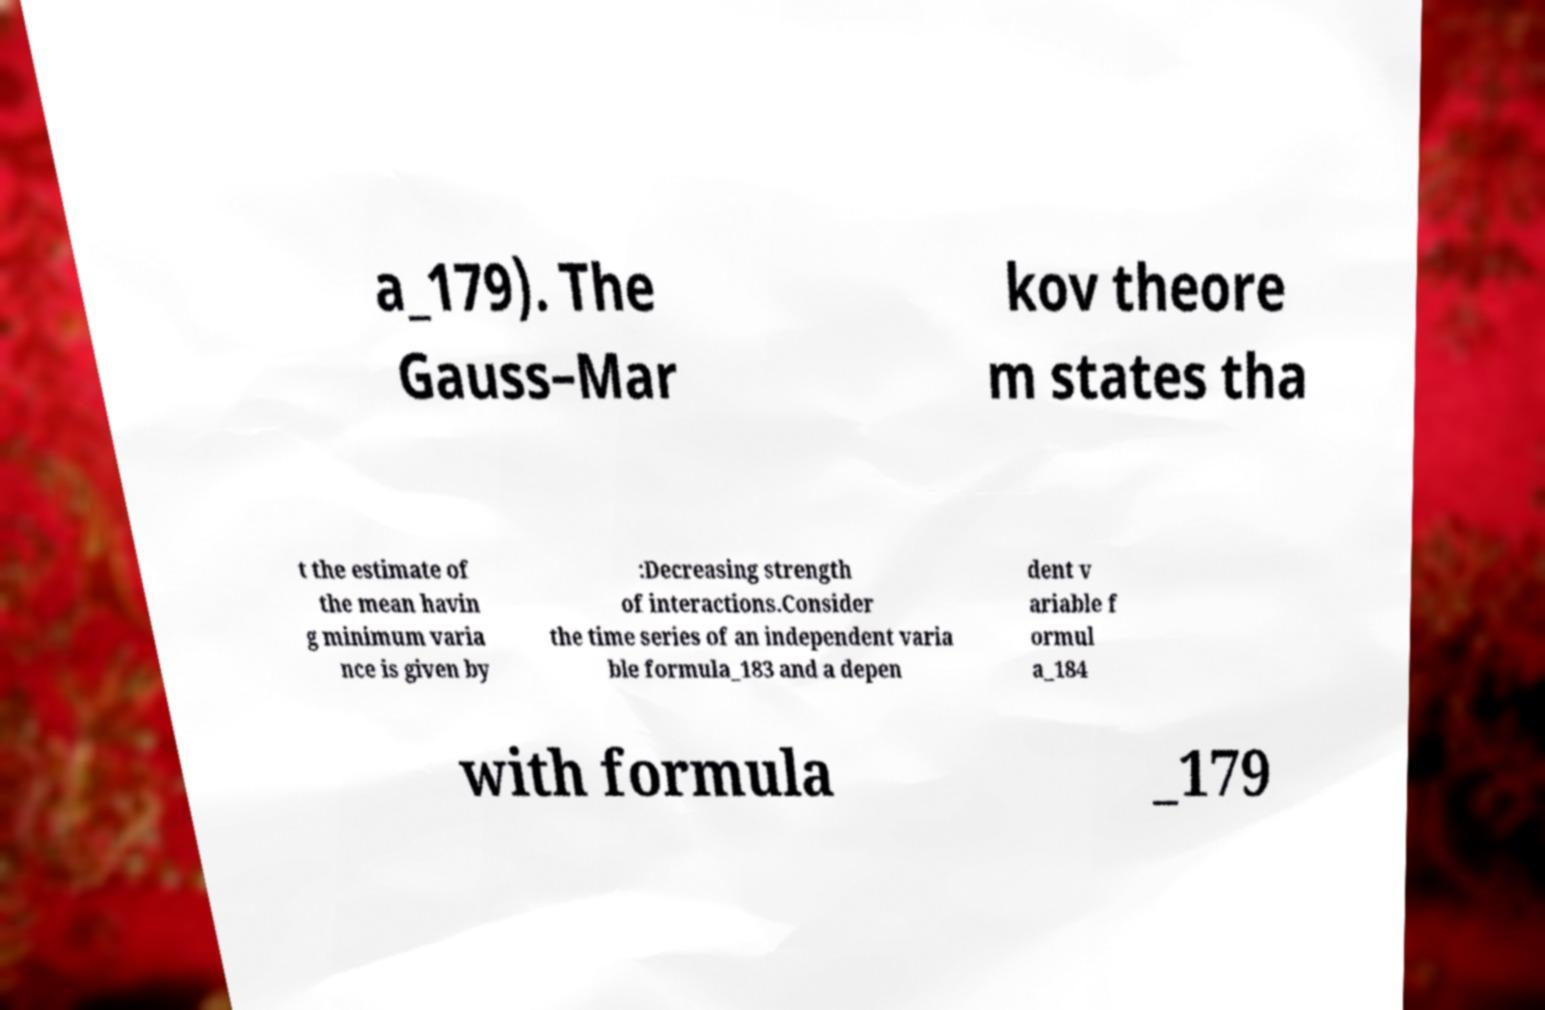Please read and relay the text visible in this image. What does it say? a_179). The Gauss–Mar kov theore m states tha t the estimate of the mean havin g minimum varia nce is given by :Decreasing strength of interactions.Consider the time series of an independent varia ble formula_183 and a depen dent v ariable f ormul a_184 with formula _179 